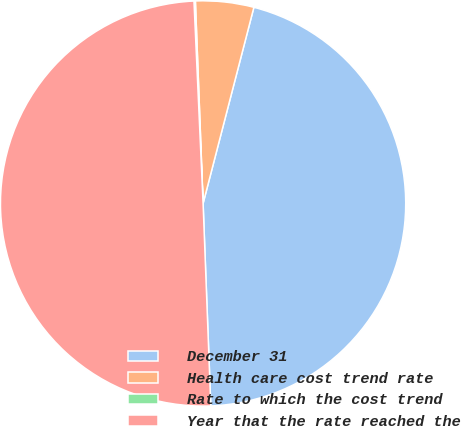<chart> <loc_0><loc_0><loc_500><loc_500><pie_chart><fcel>December 31<fcel>Health care cost trend rate<fcel>Rate to which the cost trend<fcel>Year that the rate reached the<nl><fcel>45.36%<fcel>4.64%<fcel>0.11%<fcel>49.89%<nl></chart> 